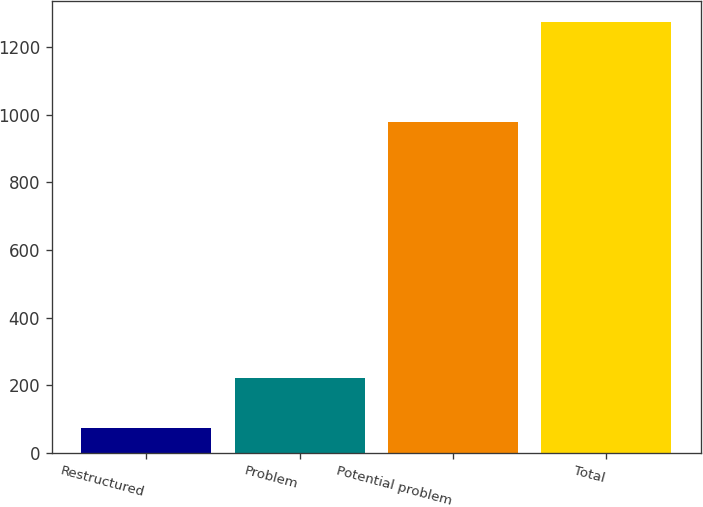<chart> <loc_0><loc_0><loc_500><loc_500><bar_chart><fcel>Restructured<fcel>Problem<fcel>Potential problem<fcel>Total<nl><fcel>75<fcel>221<fcel>977<fcel>1273<nl></chart> 